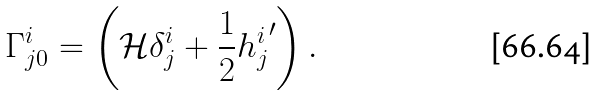<formula> <loc_0><loc_0><loc_500><loc_500>\Gamma _ { j 0 } ^ { i } = \left ( { \mathcal { H } } \delta _ { j } ^ { i } + \frac { 1 } { 2 } { h _ { j } ^ { i } } ^ { \prime } \right ) .</formula> 